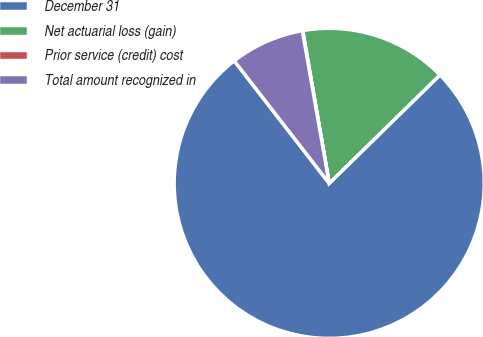<chart> <loc_0><loc_0><loc_500><loc_500><pie_chart><fcel>December 31<fcel>Net actuarial loss (gain)<fcel>Prior service (credit) cost<fcel>Total amount recognized in<nl><fcel>76.84%<fcel>15.4%<fcel>0.04%<fcel>7.72%<nl></chart> 